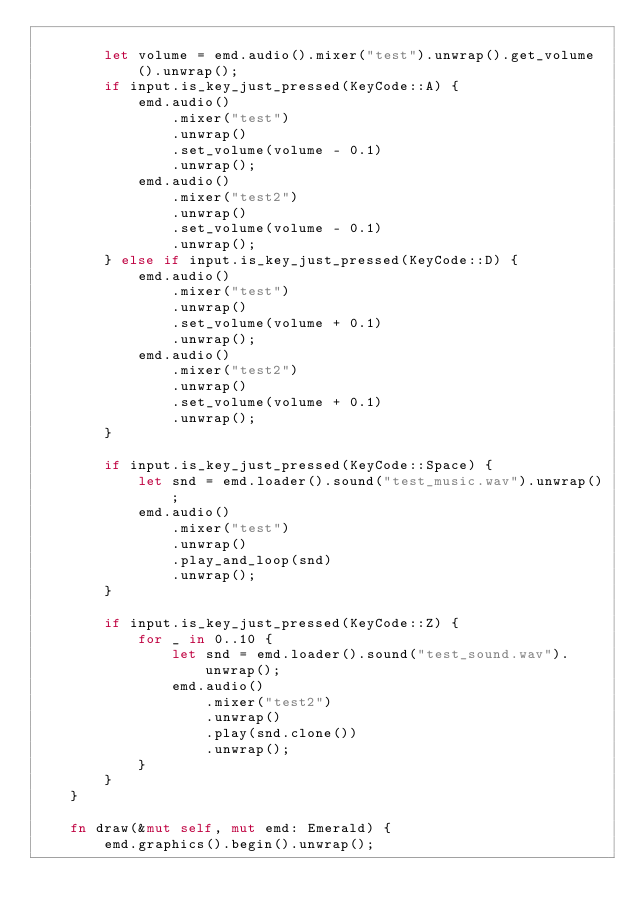<code> <loc_0><loc_0><loc_500><loc_500><_Rust_>
        let volume = emd.audio().mixer("test").unwrap().get_volume().unwrap();
        if input.is_key_just_pressed(KeyCode::A) {
            emd.audio()
                .mixer("test")
                .unwrap()
                .set_volume(volume - 0.1)
                .unwrap();
            emd.audio()
                .mixer("test2")
                .unwrap()
                .set_volume(volume - 0.1)
                .unwrap();
        } else if input.is_key_just_pressed(KeyCode::D) {
            emd.audio()
                .mixer("test")
                .unwrap()
                .set_volume(volume + 0.1)
                .unwrap();
            emd.audio()
                .mixer("test2")
                .unwrap()
                .set_volume(volume + 0.1)
                .unwrap();
        }

        if input.is_key_just_pressed(KeyCode::Space) {
            let snd = emd.loader().sound("test_music.wav").unwrap();
            emd.audio()
                .mixer("test")
                .unwrap()
                .play_and_loop(snd)
                .unwrap();
        }

        if input.is_key_just_pressed(KeyCode::Z) {
            for _ in 0..10 {
                let snd = emd.loader().sound("test_sound.wav").unwrap();
                emd.audio()
                    .mixer("test2")
                    .unwrap()
                    .play(snd.clone())
                    .unwrap();
            }
        }
    }

    fn draw(&mut self, mut emd: Emerald) {
        emd.graphics().begin().unwrap();</code> 